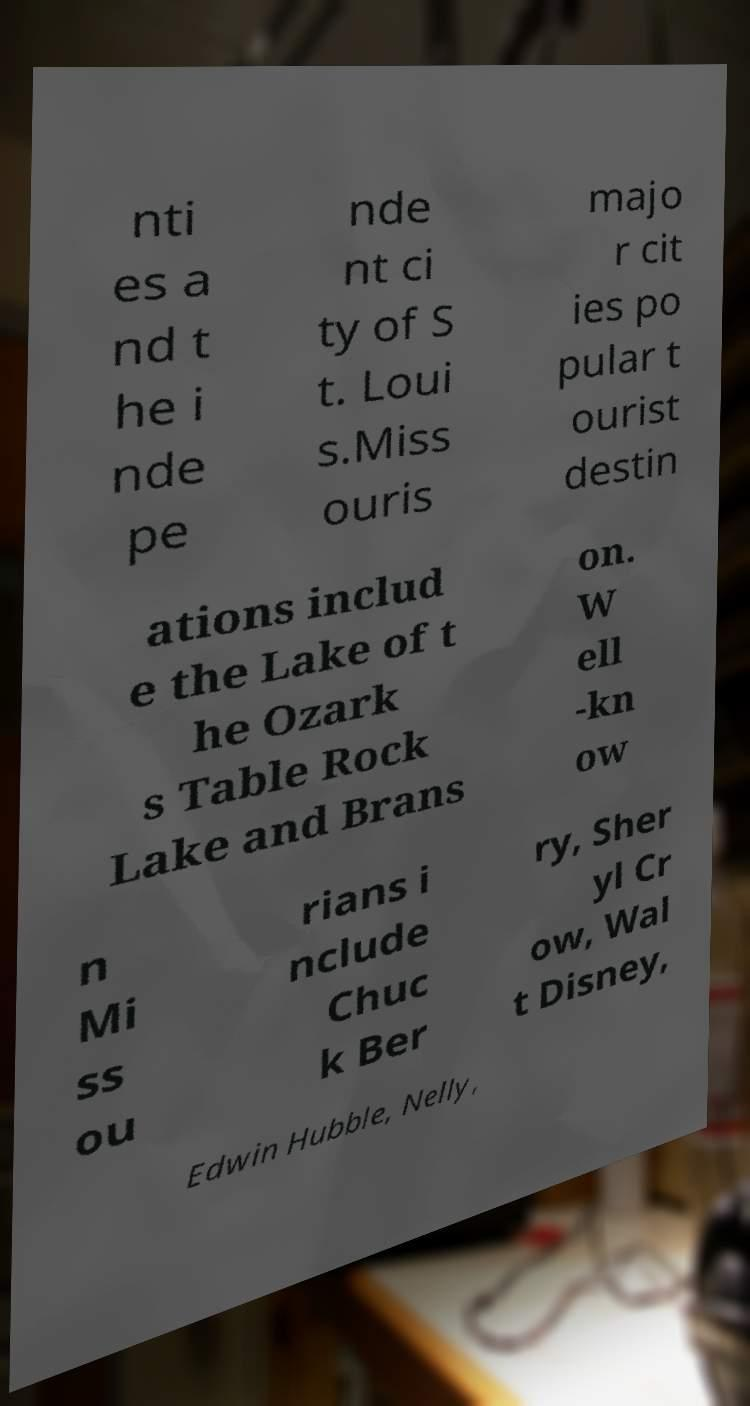Could you assist in decoding the text presented in this image and type it out clearly? nti es a nd t he i nde pe nde nt ci ty of S t. Loui s.Miss ouris majo r cit ies po pular t ourist destin ations includ e the Lake of t he Ozark s Table Rock Lake and Brans on. W ell -kn ow n Mi ss ou rians i nclude Chuc k Ber ry, Sher yl Cr ow, Wal t Disney, Edwin Hubble, Nelly, 